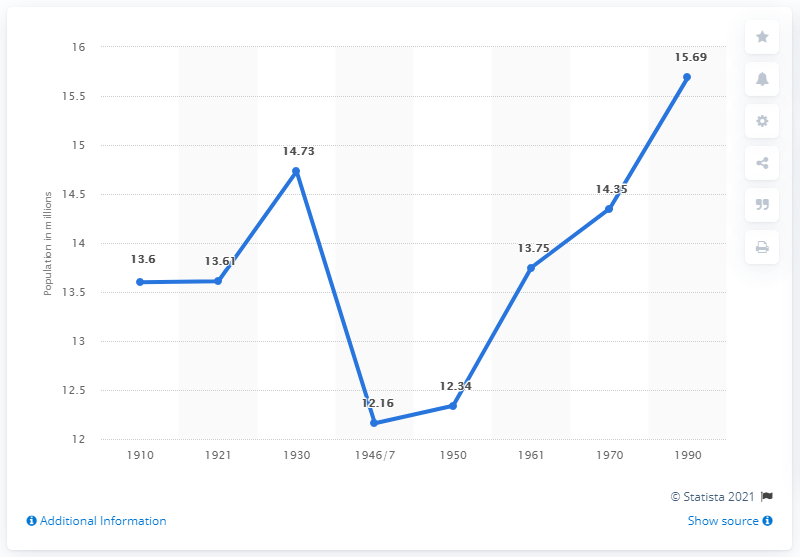Identify some key points in this picture. In 1970, the population of Czechoslovakia was 14,350,000. 